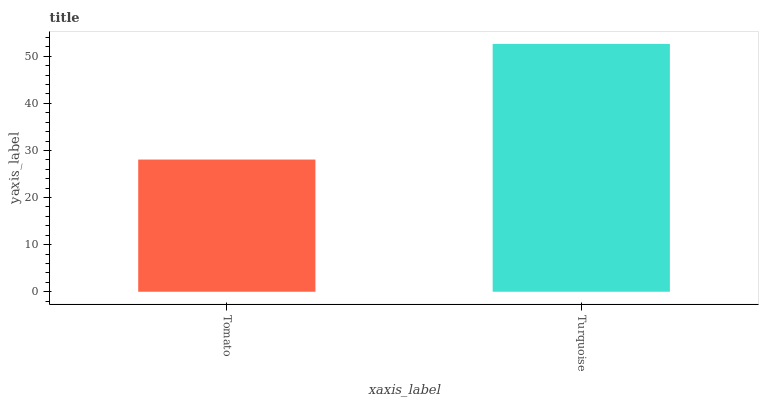Is Tomato the minimum?
Answer yes or no. Yes. Is Turquoise the maximum?
Answer yes or no. Yes. Is Turquoise the minimum?
Answer yes or no. No. Is Turquoise greater than Tomato?
Answer yes or no. Yes. Is Tomato less than Turquoise?
Answer yes or no. Yes. Is Tomato greater than Turquoise?
Answer yes or no. No. Is Turquoise less than Tomato?
Answer yes or no. No. Is Turquoise the high median?
Answer yes or no. Yes. Is Tomato the low median?
Answer yes or no. Yes. Is Tomato the high median?
Answer yes or no. No. Is Turquoise the low median?
Answer yes or no. No. 